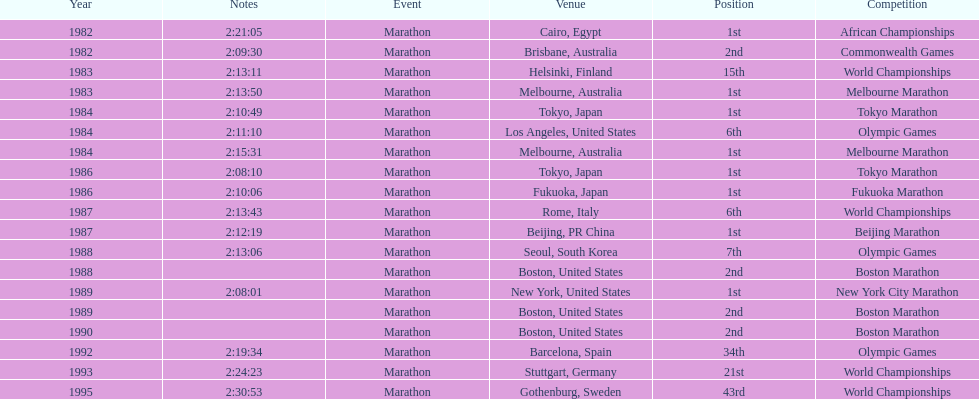What was the first marathon juma ikangaa won? 1982 African Championships. 